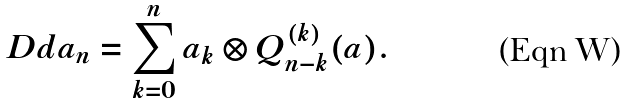Convert formula to latex. <formula><loc_0><loc_0><loc_500><loc_500>\ D d a _ { n } & = \sum _ { k = 0 } ^ { n } a _ { k } \otimes Q ^ { ( k ) } _ { n - k } ( a ) .</formula> 